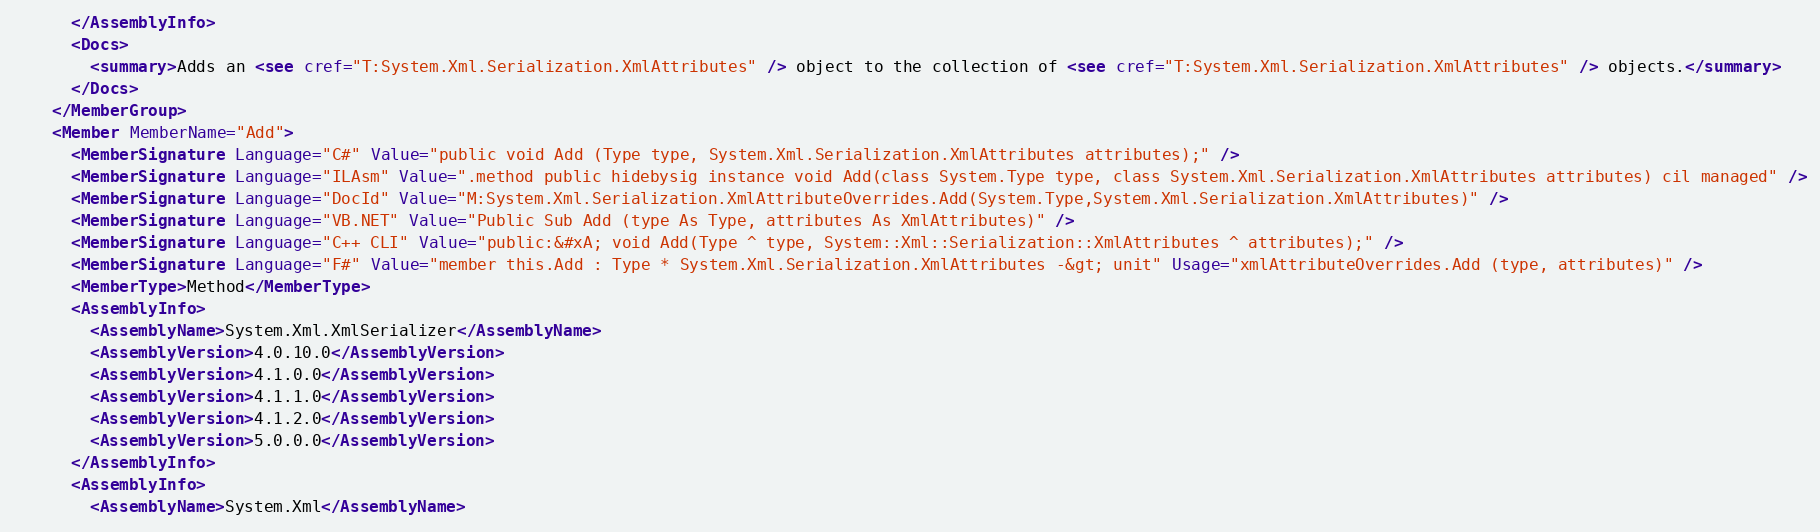Convert code to text. <code><loc_0><loc_0><loc_500><loc_500><_XML_>      </AssemblyInfo>
      <Docs>
        <summary>Adds an <see cref="T:System.Xml.Serialization.XmlAttributes" /> object to the collection of <see cref="T:System.Xml.Serialization.XmlAttributes" /> objects.</summary>
      </Docs>
    </MemberGroup>
    <Member MemberName="Add">
      <MemberSignature Language="C#" Value="public void Add (Type type, System.Xml.Serialization.XmlAttributes attributes);" />
      <MemberSignature Language="ILAsm" Value=".method public hidebysig instance void Add(class System.Type type, class System.Xml.Serialization.XmlAttributes attributes) cil managed" />
      <MemberSignature Language="DocId" Value="M:System.Xml.Serialization.XmlAttributeOverrides.Add(System.Type,System.Xml.Serialization.XmlAttributes)" />
      <MemberSignature Language="VB.NET" Value="Public Sub Add (type As Type, attributes As XmlAttributes)" />
      <MemberSignature Language="C++ CLI" Value="public:&#xA; void Add(Type ^ type, System::Xml::Serialization::XmlAttributes ^ attributes);" />
      <MemberSignature Language="F#" Value="member this.Add : Type * System.Xml.Serialization.XmlAttributes -&gt; unit" Usage="xmlAttributeOverrides.Add (type, attributes)" />
      <MemberType>Method</MemberType>
      <AssemblyInfo>
        <AssemblyName>System.Xml.XmlSerializer</AssemblyName>
        <AssemblyVersion>4.0.10.0</AssemblyVersion>
        <AssemblyVersion>4.1.0.0</AssemblyVersion>
        <AssemblyVersion>4.1.1.0</AssemblyVersion>
        <AssemblyVersion>4.1.2.0</AssemblyVersion>
        <AssemblyVersion>5.0.0.0</AssemblyVersion>
      </AssemblyInfo>
      <AssemblyInfo>
        <AssemblyName>System.Xml</AssemblyName></code> 